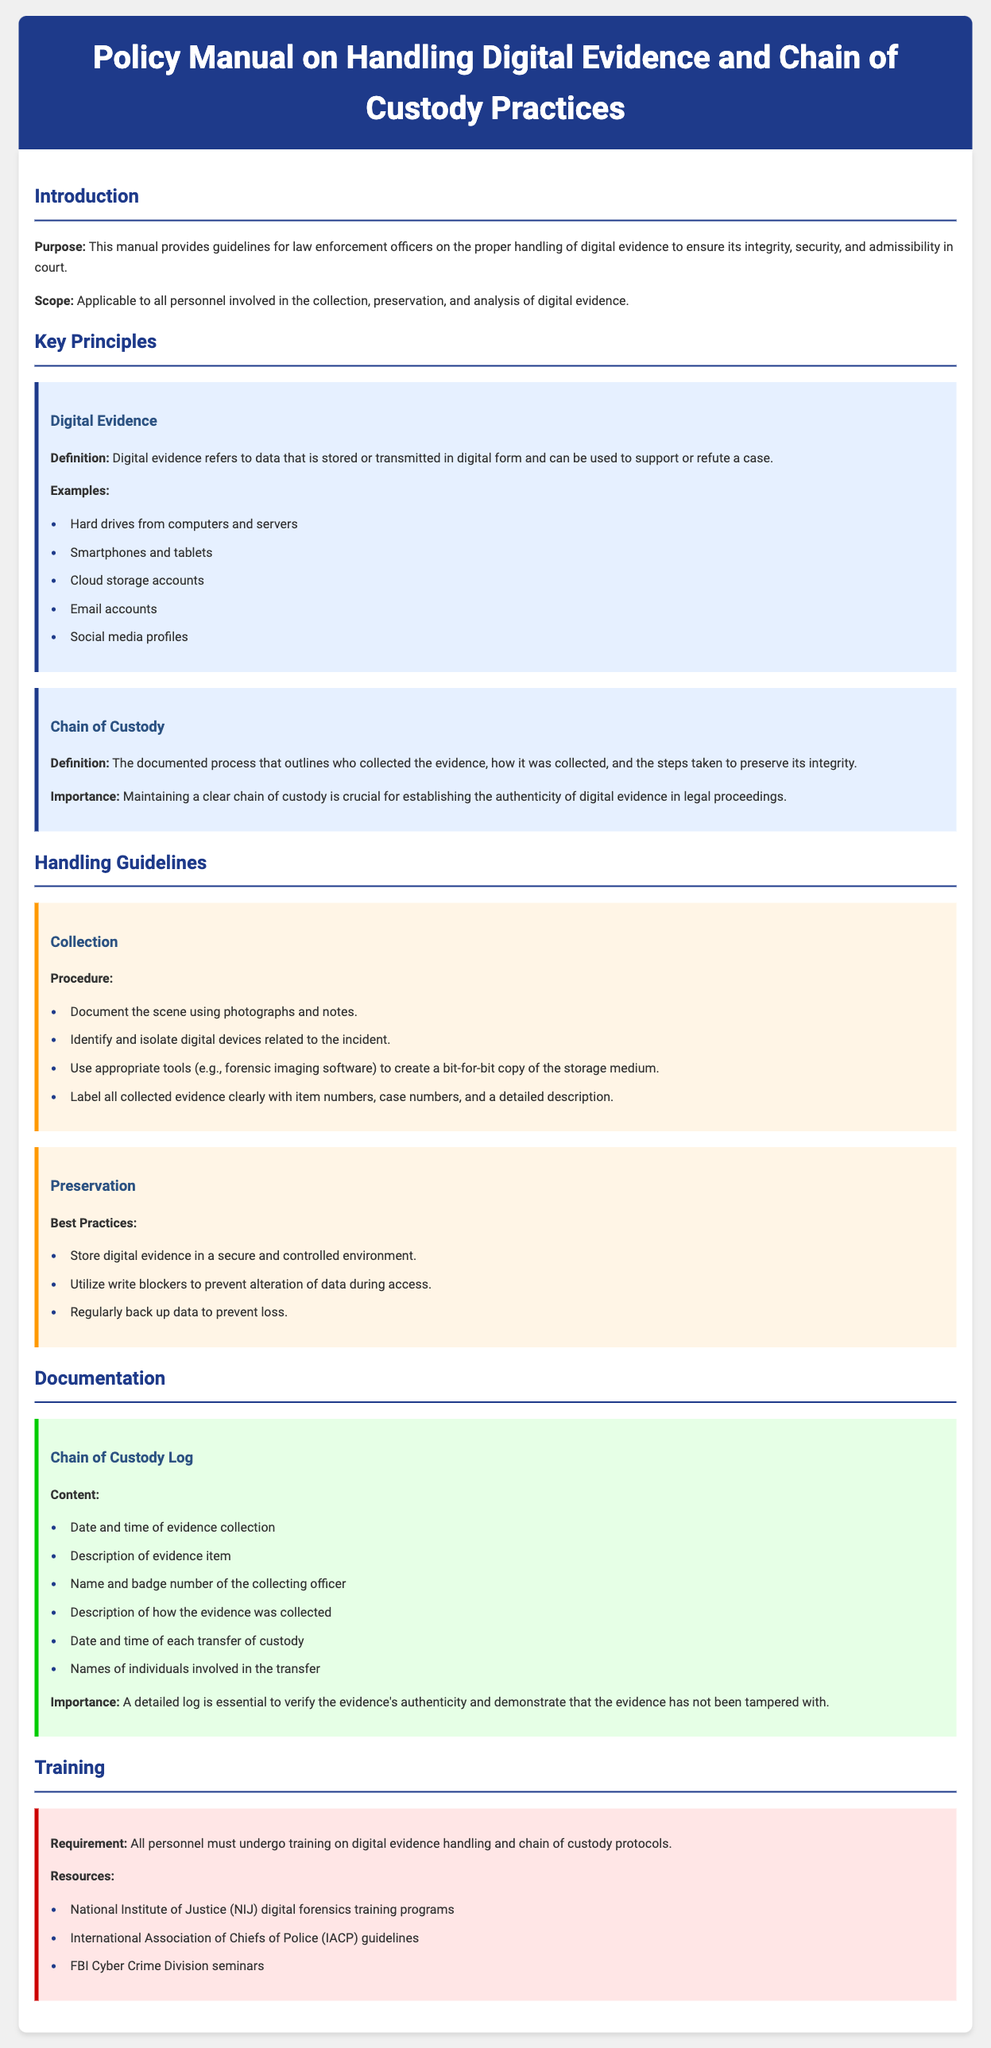What is the purpose of the manual? The purpose outlines the guidelines for law enforcement officers on handling digital evidence to ensure its integrity, security, and admissibility in court.
Answer: guidelines for law enforcement officers on handling digital evidence What are examples of digital evidence? The examples of digital evidence are listed in the section about Digital Evidence and include various items from computers to social media.
Answer: Hard drives, smartphones, cloud storage, email accounts, social media profiles What is a key principle of chain of custody? The key principle states that the documented process ensuring the authenticity of evidence in legal proceedings is crucial.
Answer: authenticity of digital evidence Name one best practice for preserving digital evidence. This is found in the section on Preservation and highlights actions that should be undertaken to maintain the integrity of digital evidence.
Answer: Store evidence in a secure environment What content should be included in a Chain of Custody Log? The Chain of Custody Log is specified to include detailed aspects regarding the evidence collection and transfer process.
Answer: Date and time of evidence collection, description of evidence item, name/badge of officer What is a training requirement mentioned in the manual? The manual mentions that training is essential for personnel regarding protocols on digital evidence handling and chain of custody.
Answer: All personnel must undergo training What is an example of a resource for training? The manual lists resources that provide guidance and education on handling digital evidence.
Answer: National Institute of Justice digital forensics training programs 